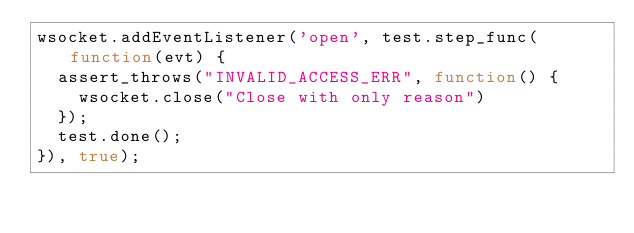<code> <loc_0><loc_0><loc_500><loc_500><_JavaScript_>wsocket.addEventListener('open', test.step_func(function(evt) {
  assert_throws("INVALID_ACCESS_ERR", function() {
    wsocket.close("Close with only reason")
  });
  test.done();
}), true);
</code> 